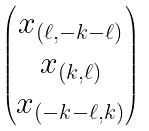<formula> <loc_0><loc_0><loc_500><loc_500>\begin{pmatrix} x _ { ( \ell , - k - \ell ) } \\ x _ { ( k , \ell ) } \\ x _ { ( - k - \ell , k ) } \end{pmatrix}</formula> 